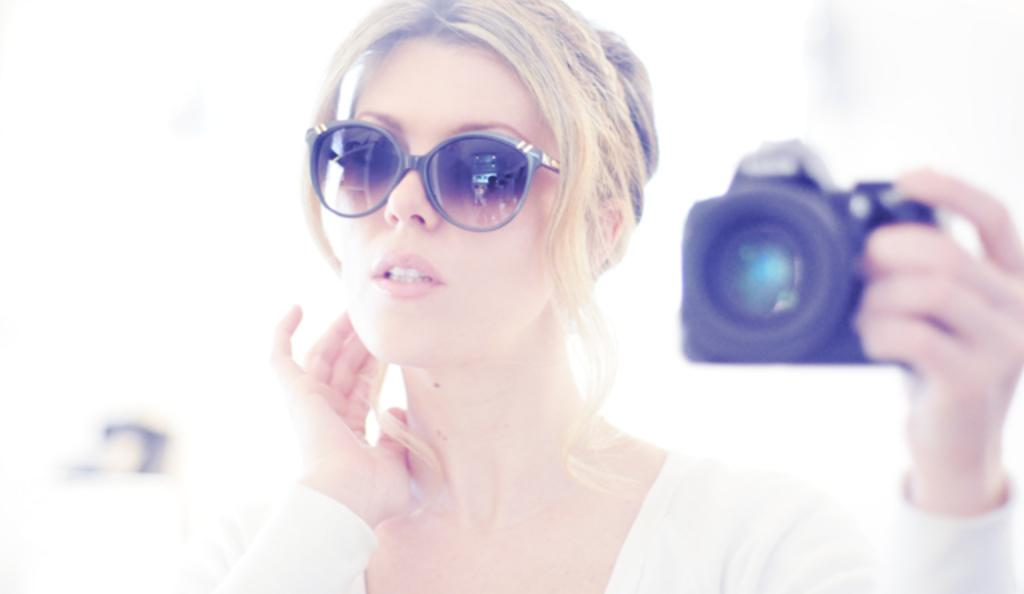Who is the main subject in the image? There is a woman in the image. What is the woman wearing? The woman is wearing spectacles. What is the woman holding in the image? The woman is holding a camera. What might the woman be doing in the image? The woman is giving a still, possibly posing for a photograph. Can you see an apple in the image? No, there is no apple present in the image. What trick is the woman performing in the image? There is no trick being performed in the image; the woman is simply posing for a photograph. 